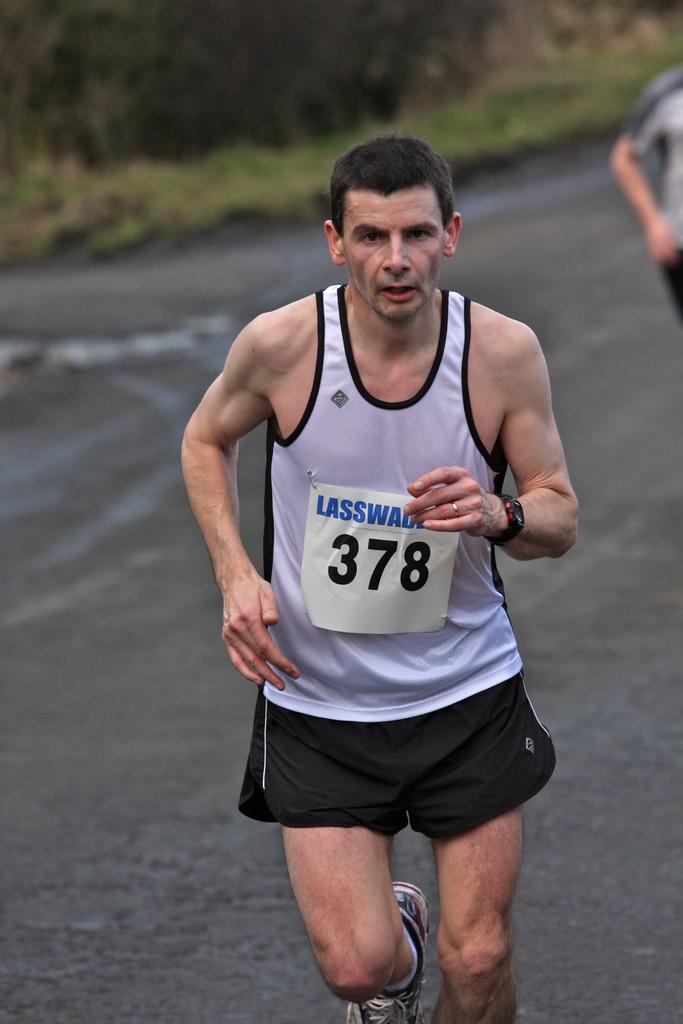What entrant number is this runner?
Offer a very short reply. 378. What is the name of the race on the man's bib?
Ensure brevity in your answer.  Lasswad. 